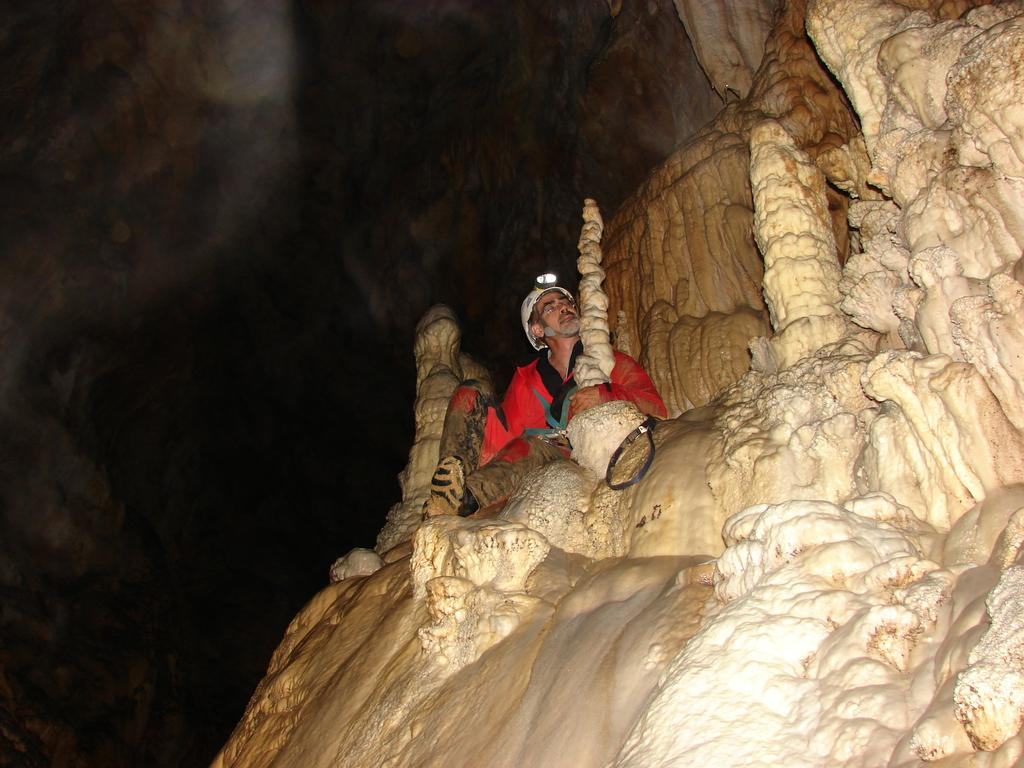What is the main subject of the image? There is a person in the image. Can you describe the setting where the person is located? The person is sitting inside a cave. What type of glass object is the person holding in the image? There is no glass object present in the image. How does the person light a match inside the cave? There is no match or any indication of fire in the image. 